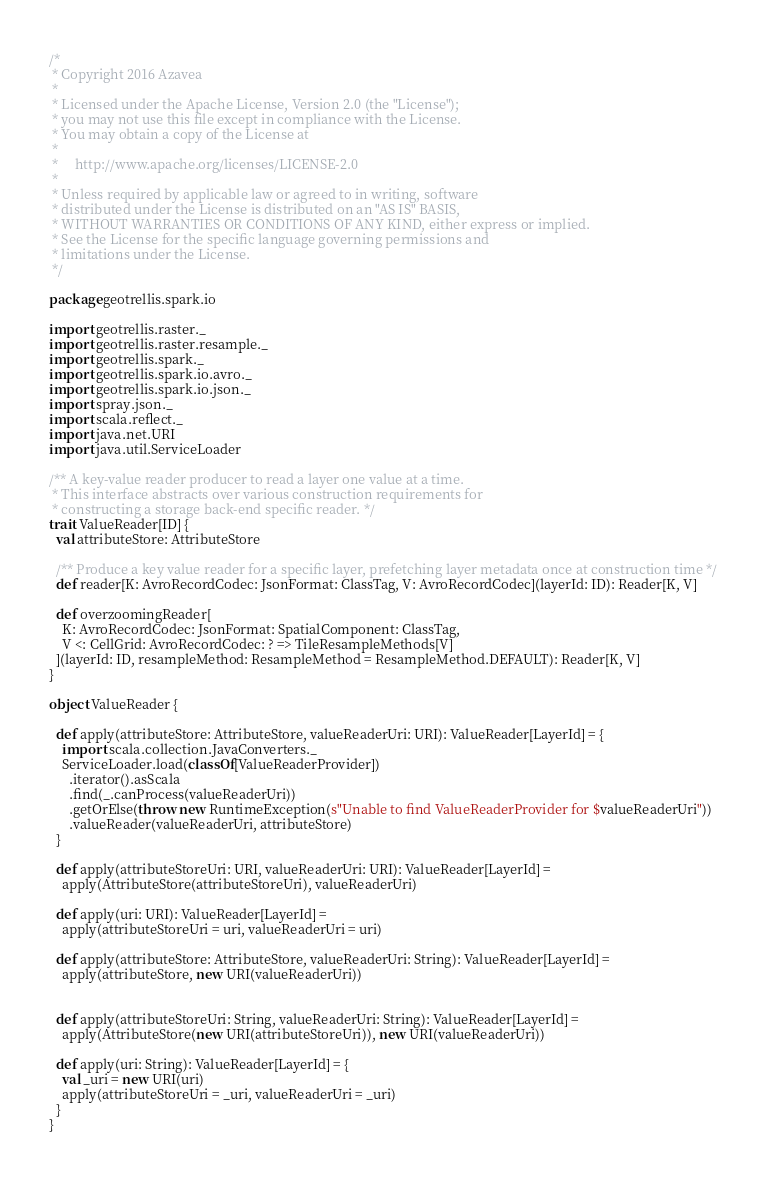Convert code to text. <code><loc_0><loc_0><loc_500><loc_500><_Scala_>/*
 * Copyright 2016 Azavea
 *
 * Licensed under the Apache License, Version 2.0 (the "License");
 * you may not use this file except in compliance with the License.
 * You may obtain a copy of the License at
 *
 *     http://www.apache.org/licenses/LICENSE-2.0
 *
 * Unless required by applicable law or agreed to in writing, software
 * distributed under the License is distributed on an "AS IS" BASIS,
 * WITHOUT WARRANTIES OR CONDITIONS OF ANY KIND, either express or implied.
 * See the License for the specific language governing permissions and
 * limitations under the License.
 */

package geotrellis.spark.io

import geotrellis.raster._
import geotrellis.raster.resample._
import geotrellis.spark._
import geotrellis.spark.io.avro._
import geotrellis.spark.io.json._
import spray.json._
import scala.reflect._
import java.net.URI
import java.util.ServiceLoader

/** A key-value reader producer to read a layer one value at a time.
 * This interface abstracts over various construction requirements for
 * constructing a storage back-end specific reader. */
trait ValueReader[ID] {
  val attributeStore: AttributeStore

  /** Produce a key value reader for a specific layer, prefetching layer metadata once at construction time */
  def reader[K: AvroRecordCodec: JsonFormat: ClassTag, V: AvroRecordCodec](layerId: ID): Reader[K, V]

  def overzoomingReader[
    K: AvroRecordCodec: JsonFormat: SpatialComponent: ClassTag, 
    V <: CellGrid: AvroRecordCodec: ? => TileResampleMethods[V]
  ](layerId: ID, resampleMethod: ResampleMethod = ResampleMethod.DEFAULT): Reader[K, V]
}

object ValueReader {

  def apply(attributeStore: AttributeStore, valueReaderUri: URI): ValueReader[LayerId] = {
    import scala.collection.JavaConverters._
    ServiceLoader.load(classOf[ValueReaderProvider])
      .iterator().asScala
      .find(_.canProcess(valueReaderUri))
      .getOrElse(throw new RuntimeException(s"Unable to find ValueReaderProvider for $valueReaderUri"))
      .valueReader(valueReaderUri, attributeStore)
  }

  def apply(attributeStoreUri: URI, valueReaderUri: URI): ValueReader[LayerId] =
    apply(AttributeStore(attributeStoreUri), valueReaderUri)

  def apply(uri: URI): ValueReader[LayerId] =
    apply(attributeStoreUri = uri, valueReaderUri = uri)

  def apply(attributeStore: AttributeStore, valueReaderUri: String): ValueReader[LayerId] =
    apply(attributeStore, new URI(valueReaderUri))


  def apply(attributeStoreUri: String, valueReaderUri: String): ValueReader[LayerId] =
    apply(AttributeStore(new URI(attributeStoreUri)), new URI(valueReaderUri))

  def apply(uri: String): ValueReader[LayerId] = {
    val _uri = new URI(uri)
    apply(attributeStoreUri = _uri, valueReaderUri = _uri)
  }
}
</code> 